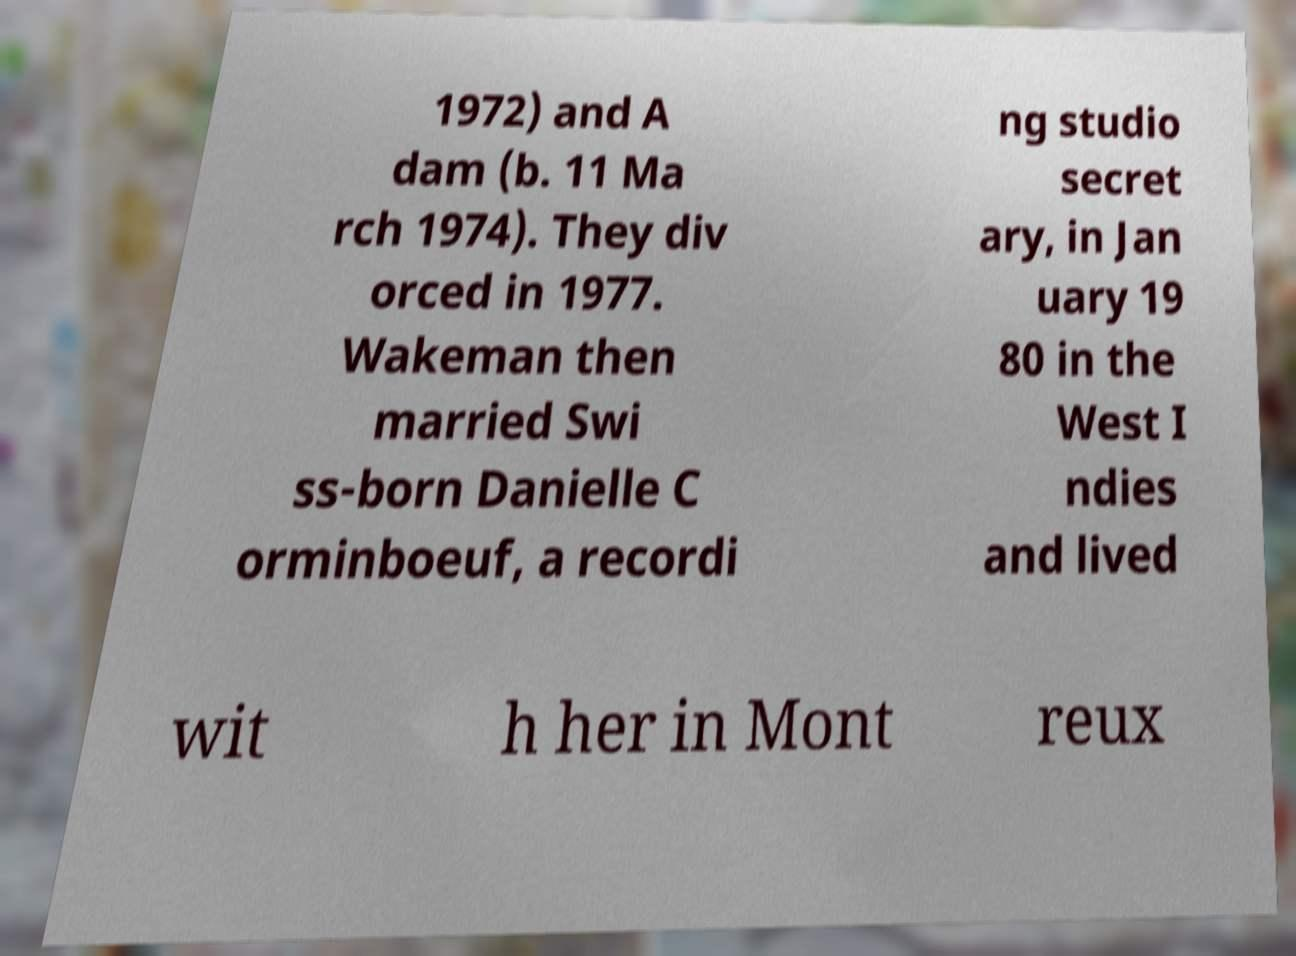Could you extract and type out the text from this image? 1972) and A dam (b. 11 Ma rch 1974). They div orced in 1977. Wakeman then married Swi ss-born Danielle C orminboeuf, a recordi ng studio secret ary, in Jan uary 19 80 in the West I ndies and lived wit h her in Mont reux 